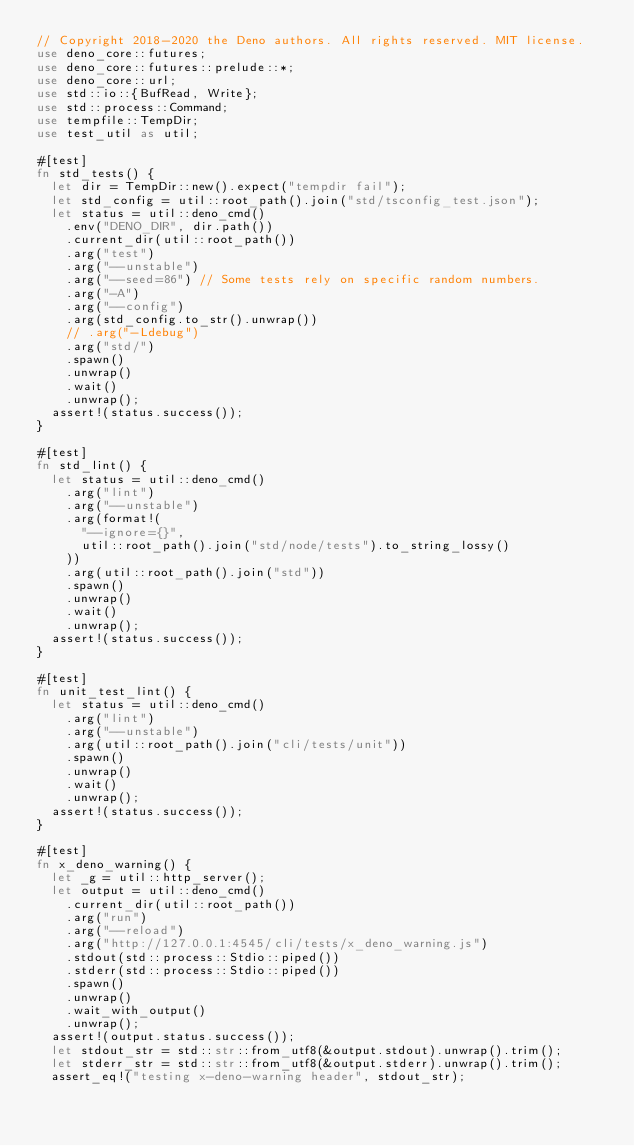<code> <loc_0><loc_0><loc_500><loc_500><_Rust_>// Copyright 2018-2020 the Deno authors. All rights reserved. MIT license.
use deno_core::futures;
use deno_core::futures::prelude::*;
use deno_core::url;
use std::io::{BufRead, Write};
use std::process::Command;
use tempfile::TempDir;
use test_util as util;

#[test]
fn std_tests() {
  let dir = TempDir::new().expect("tempdir fail");
  let std_config = util::root_path().join("std/tsconfig_test.json");
  let status = util::deno_cmd()
    .env("DENO_DIR", dir.path())
    .current_dir(util::root_path())
    .arg("test")
    .arg("--unstable")
    .arg("--seed=86") // Some tests rely on specific random numbers.
    .arg("-A")
    .arg("--config")
    .arg(std_config.to_str().unwrap())
    // .arg("-Ldebug")
    .arg("std/")
    .spawn()
    .unwrap()
    .wait()
    .unwrap();
  assert!(status.success());
}

#[test]
fn std_lint() {
  let status = util::deno_cmd()
    .arg("lint")
    .arg("--unstable")
    .arg(format!(
      "--ignore={}",
      util::root_path().join("std/node/tests").to_string_lossy()
    ))
    .arg(util::root_path().join("std"))
    .spawn()
    .unwrap()
    .wait()
    .unwrap();
  assert!(status.success());
}

#[test]
fn unit_test_lint() {
  let status = util::deno_cmd()
    .arg("lint")
    .arg("--unstable")
    .arg(util::root_path().join("cli/tests/unit"))
    .spawn()
    .unwrap()
    .wait()
    .unwrap();
  assert!(status.success());
}

#[test]
fn x_deno_warning() {
  let _g = util::http_server();
  let output = util::deno_cmd()
    .current_dir(util::root_path())
    .arg("run")
    .arg("--reload")
    .arg("http://127.0.0.1:4545/cli/tests/x_deno_warning.js")
    .stdout(std::process::Stdio::piped())
    .stderr(std::process::Stdio::piped())
    .spawn()
    .unwrap()
    .wait_with_output()
    .unwrap();
  assert!(output.status.success());
  let stdout_str = std::str::from_utf8(&output.stdout).unwrap().trim();
  let stderr_str = std::str::from_utf8(&output.stderr).unwrap().trim();
  assert_eq!("testing x-deno-warning header", stdout_str);</code> 